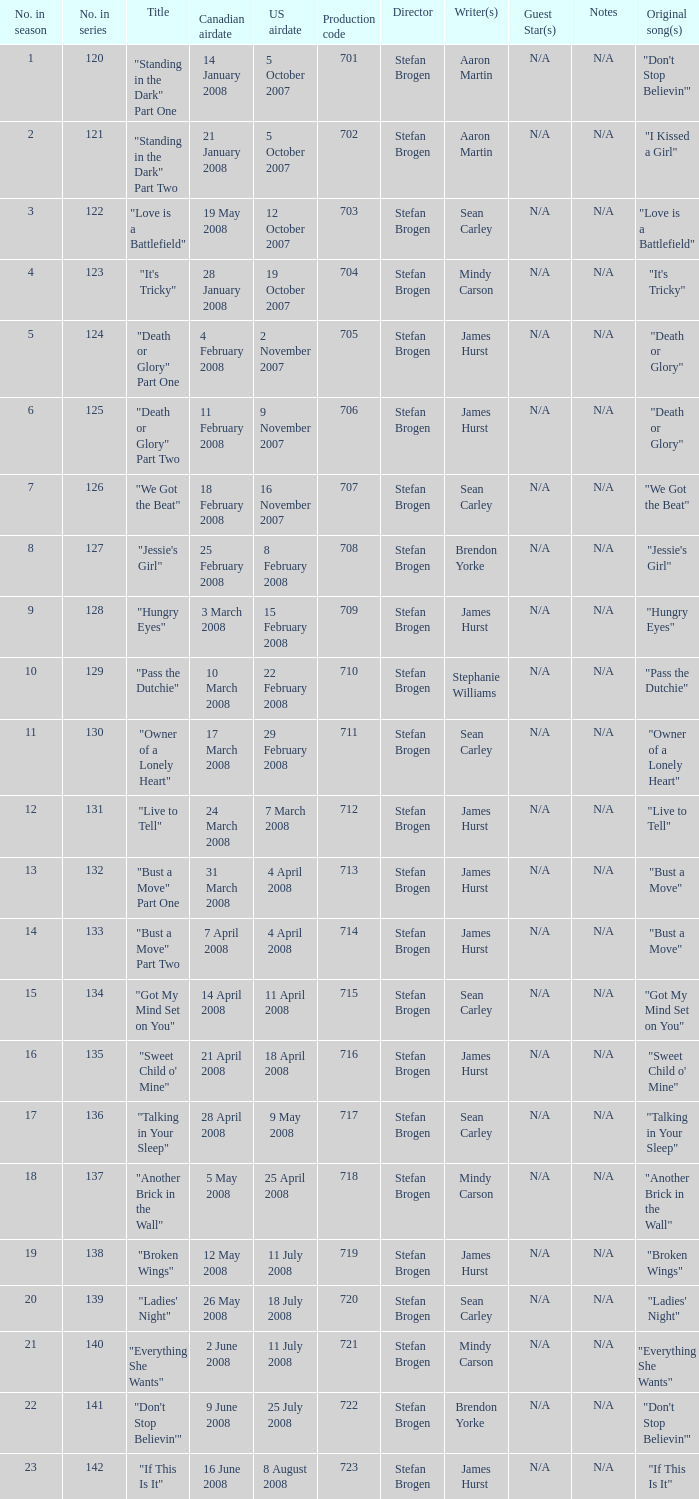The U.S. airdate of 4 april 2008 had a production code of what? 714.0. 